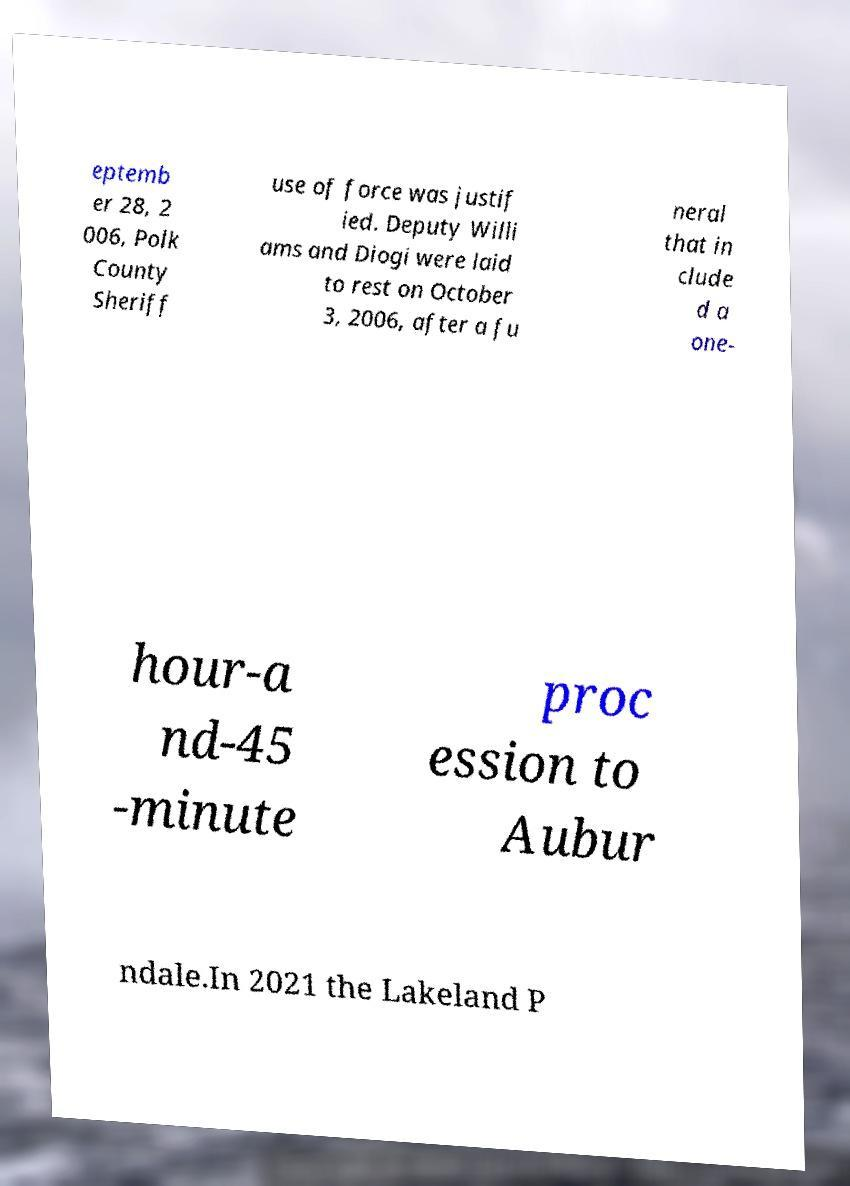For documentation purposes, I need the text within this image transcribed. Could you provide that? eptemb er 28, 2 006, Polk County Sheriff use of force was justif ied. Deputy Willi ams and Diogi were laid to rest on October 3, 2006, after a fu neral that in clude d a one- hour-a nd-45 -minute proc ession to Aubur ndale.In 2021 the Lakeland P 